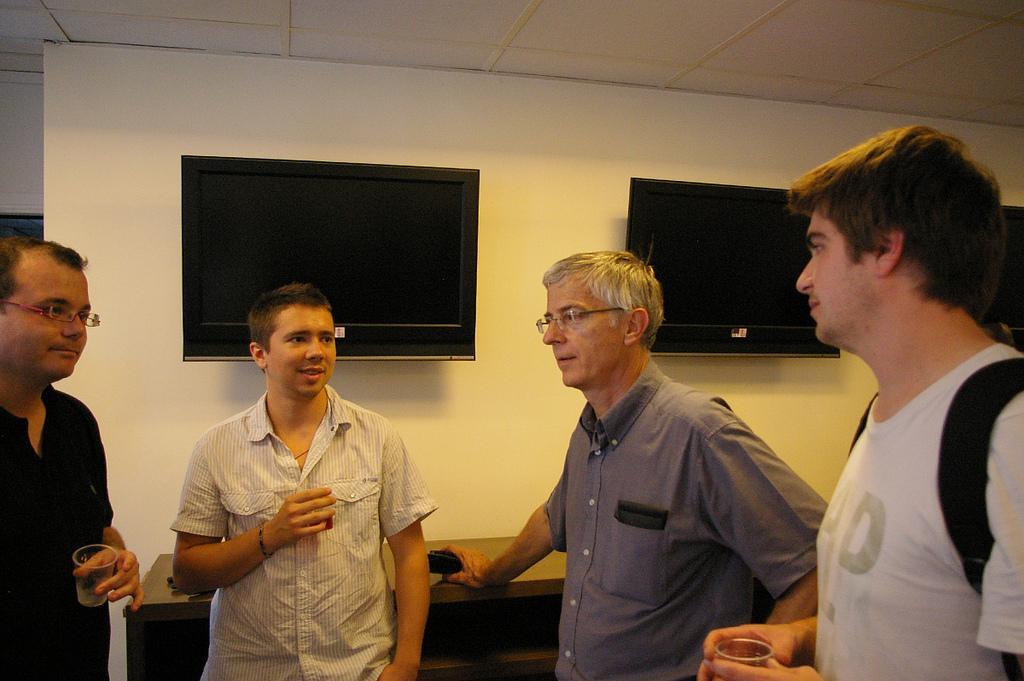Please provide a concise description of this image. In this image we can see four people standing. Two persons are wearing specs. Three are holding glasses. In the background there is a wall with televisions. Also there is a cabinet near to the wall. 